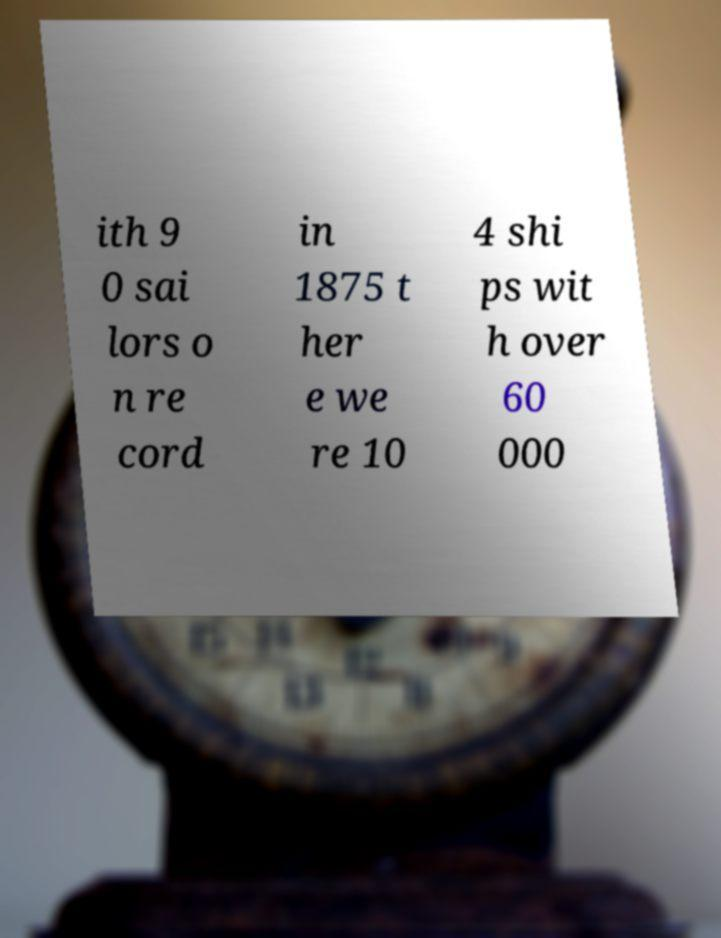For documentation purposes, I need the text within this image transcribed. Could you provide that? ith 9 0 sai lors o n re cord in 1875 t her e we re 10 4 shi ps wit h over 60 000 